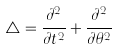Convert formula to latex. <formula><loc_0><loc_0><loc_500><loc_500>\triangle = \frac { \partial ^ { 2 } } { \partial t ^ { 2 } } + \frac { \partial ^ { 2 } } { \partial \theta ^ { 2 } }</formula> 